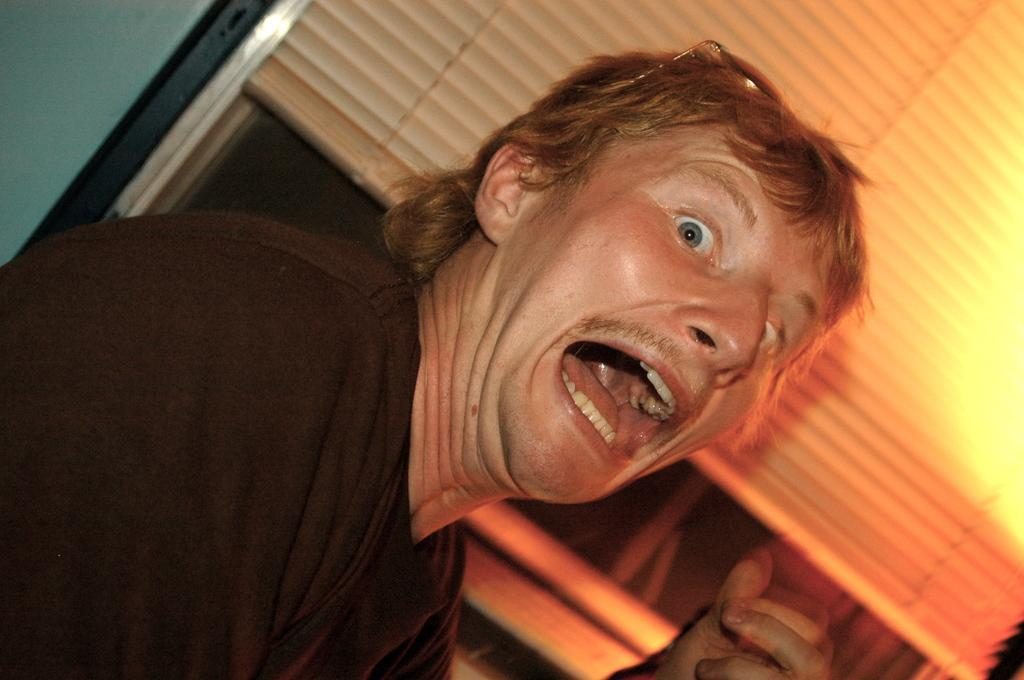What is the main subject of the image? There is a man in the image. What is the man wearing? The man is wearing a black t-shirt. Are there any accessories visible on the man? Yes, the man has spectacles on his head. What can be seen in the background of the image? There are blinds on a window in the image. Can you tell me how the man is controlling his smile in the image? There is no mention of a smile in the image, so it is not possible to determine how the man might be controlling it. 